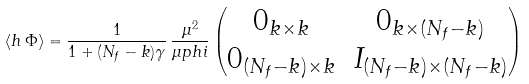Convert formula to latex. <formula><loc_0><loc_0><loc_500><loc_500>\langle h \, \Phi \rangle = \frac { 1 } { 1 + ( N _ { f } - k ) \gamma } \, \frac { \mu ^ { 2 } } { \mu p h i } \left ( \begin{matrix} 0 _ { k \times k } & 0 _ { k \times ( N _ { f } - k ) } \\ 0 _ { ( N _ { f } - k ) \times k } & I _ { ( N _ { f } - k ) \times ( N _ { f } - k ) } \end{matrix} \right )</formula> 